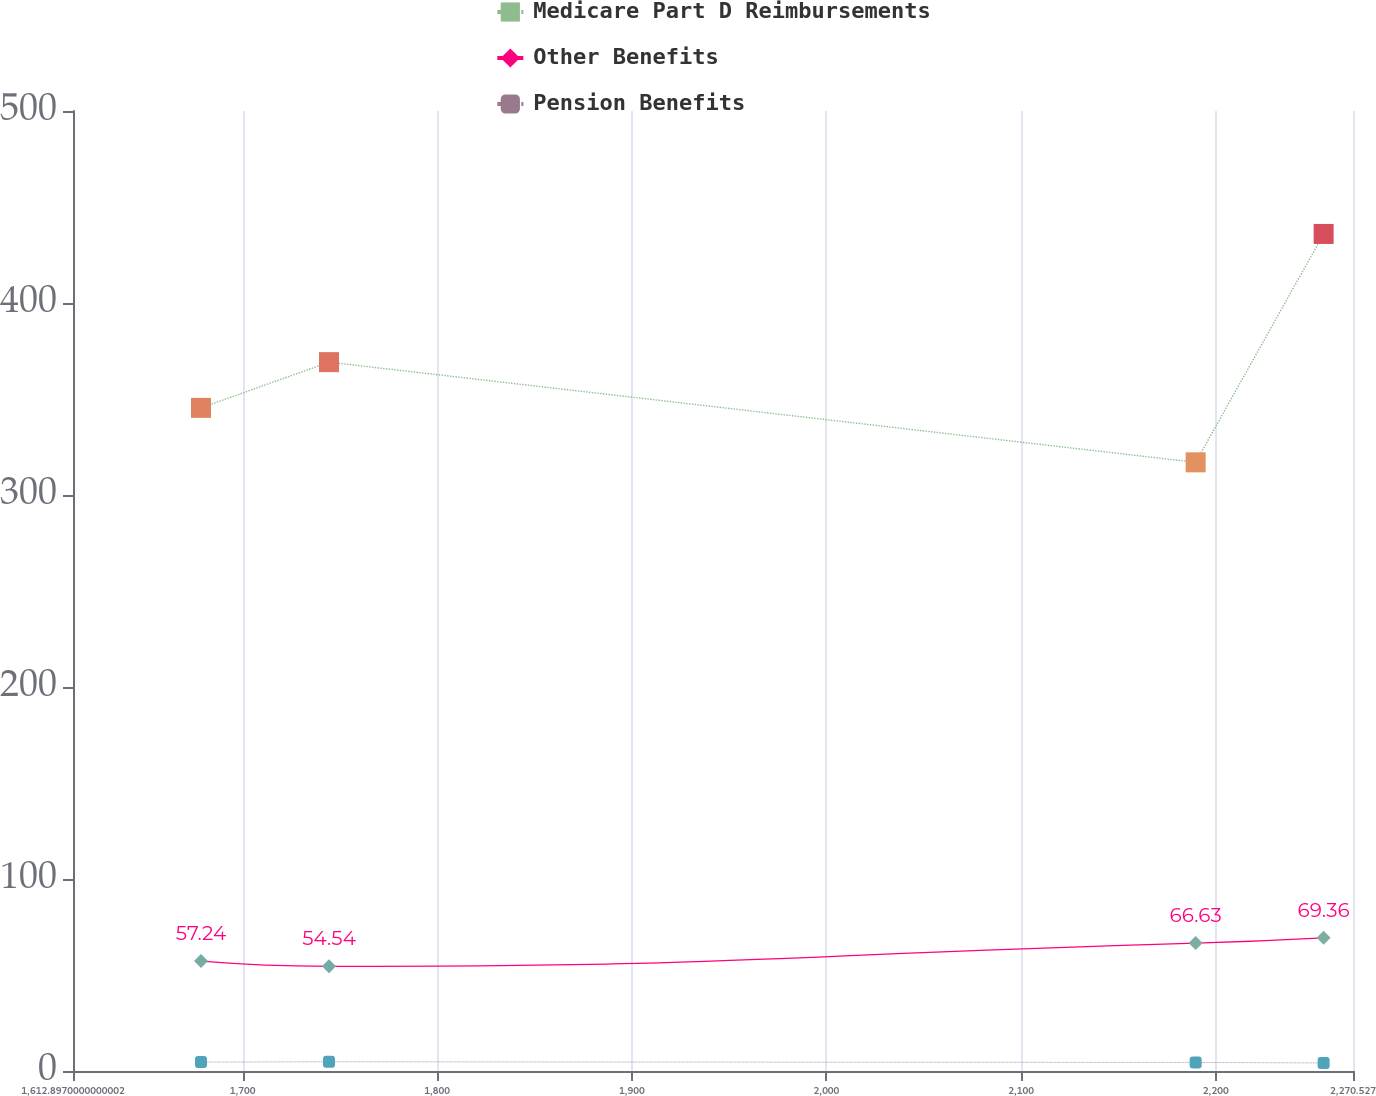Convert chart to OTSL. <chart><loc_0><loc_0><loc_500><loc_500><line_chart><ecel><fcel>Medicare Part D Reimbursements<fcel>Other Benefits<fcel>Pension Benefits<nl><fcel>1678.66<fcel>345.39<fcel>57.24<fcel>4.65<nl><fcel>1744.42<fcel>369.19<fcel>54.54<fcel>4.8<nl><fcel>2189.68<fcel>317.01<fcel>66.63<fcel>4.45<nl><fcel>2255.44<fcel>435.97<fcel>69.36<fcel>4.2<nl><fcel>2336.29<fcel>357.29<fcel>81.53<fcel>5.7<nl></chart> 